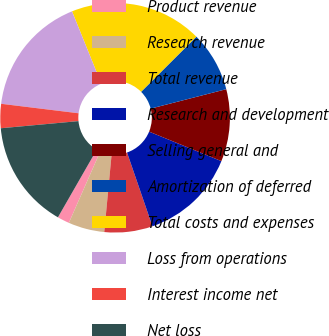Convert chart. <chart><loc_0><loc_0><loc_500><loc_500><pie_chart><fcel>Product revenue<fcel>Research revenue<fcel>Total revenue<fcel>Research and development<fcel>Selling general and<fcel>Amortization of deferred<fcel>Total costs and expenses<fcel>Loss from operations<fcel>Interest income net<fcel>Net loss<nl><fcel>1.7%<fcel>5.09%<fcel>6.78%<fcel>13.56%<fcel>10.17%<fcel>8.48%<fcel>18.64%<fcel>16.94%<fcel>3.4%<fcel>15.25%<nl></chart> 